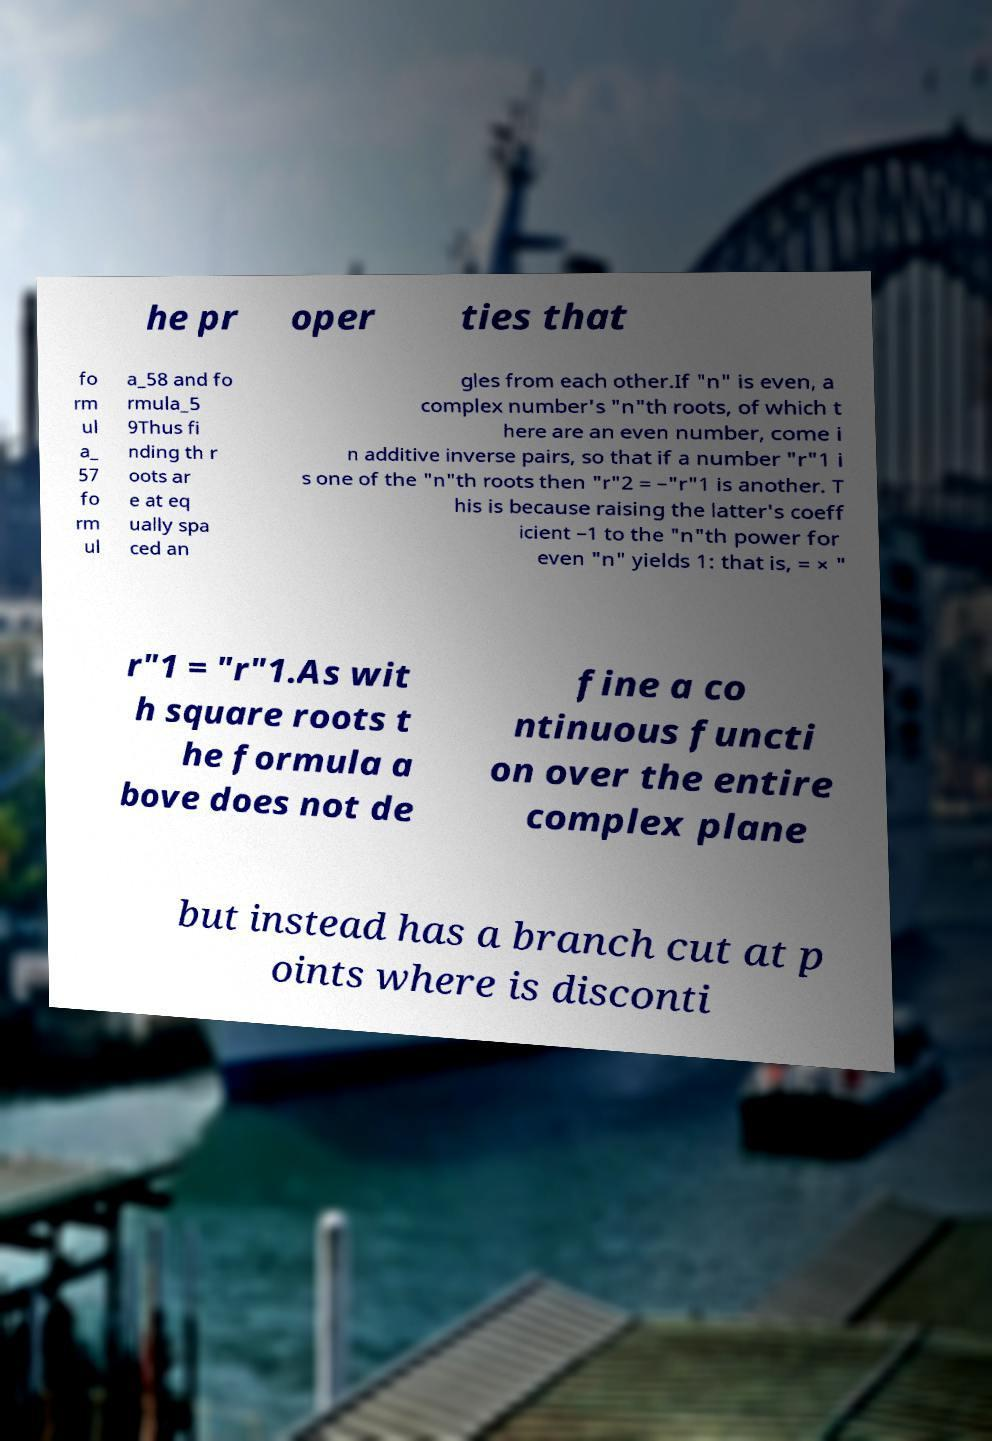Please read and relay the text visible in this image. What does it say? he pr oper ties that fo rm ul a_ 57 fo rm ul a_58 and fo rmula_5 9Thus fi nding th r oots ar e at eq ually spa ced an gles from each other.If "n" is even, a complex number's "n"th roots, of which t here are an even number, come i n additive inverse pairs, so that if a number "r"1 i s one of the "n"th roots then "r"2 = –"r"1 is another. T his is because raising the latter's coeff icient –1 to the "n"th power for even "n" yields 1: that is, = × " r"1 = "r"1.As wit h square roots t he formula a bove does not de fine a co ntinuous functi on over the entire complex plane but instead has a branch cut at p oints where is disconti 